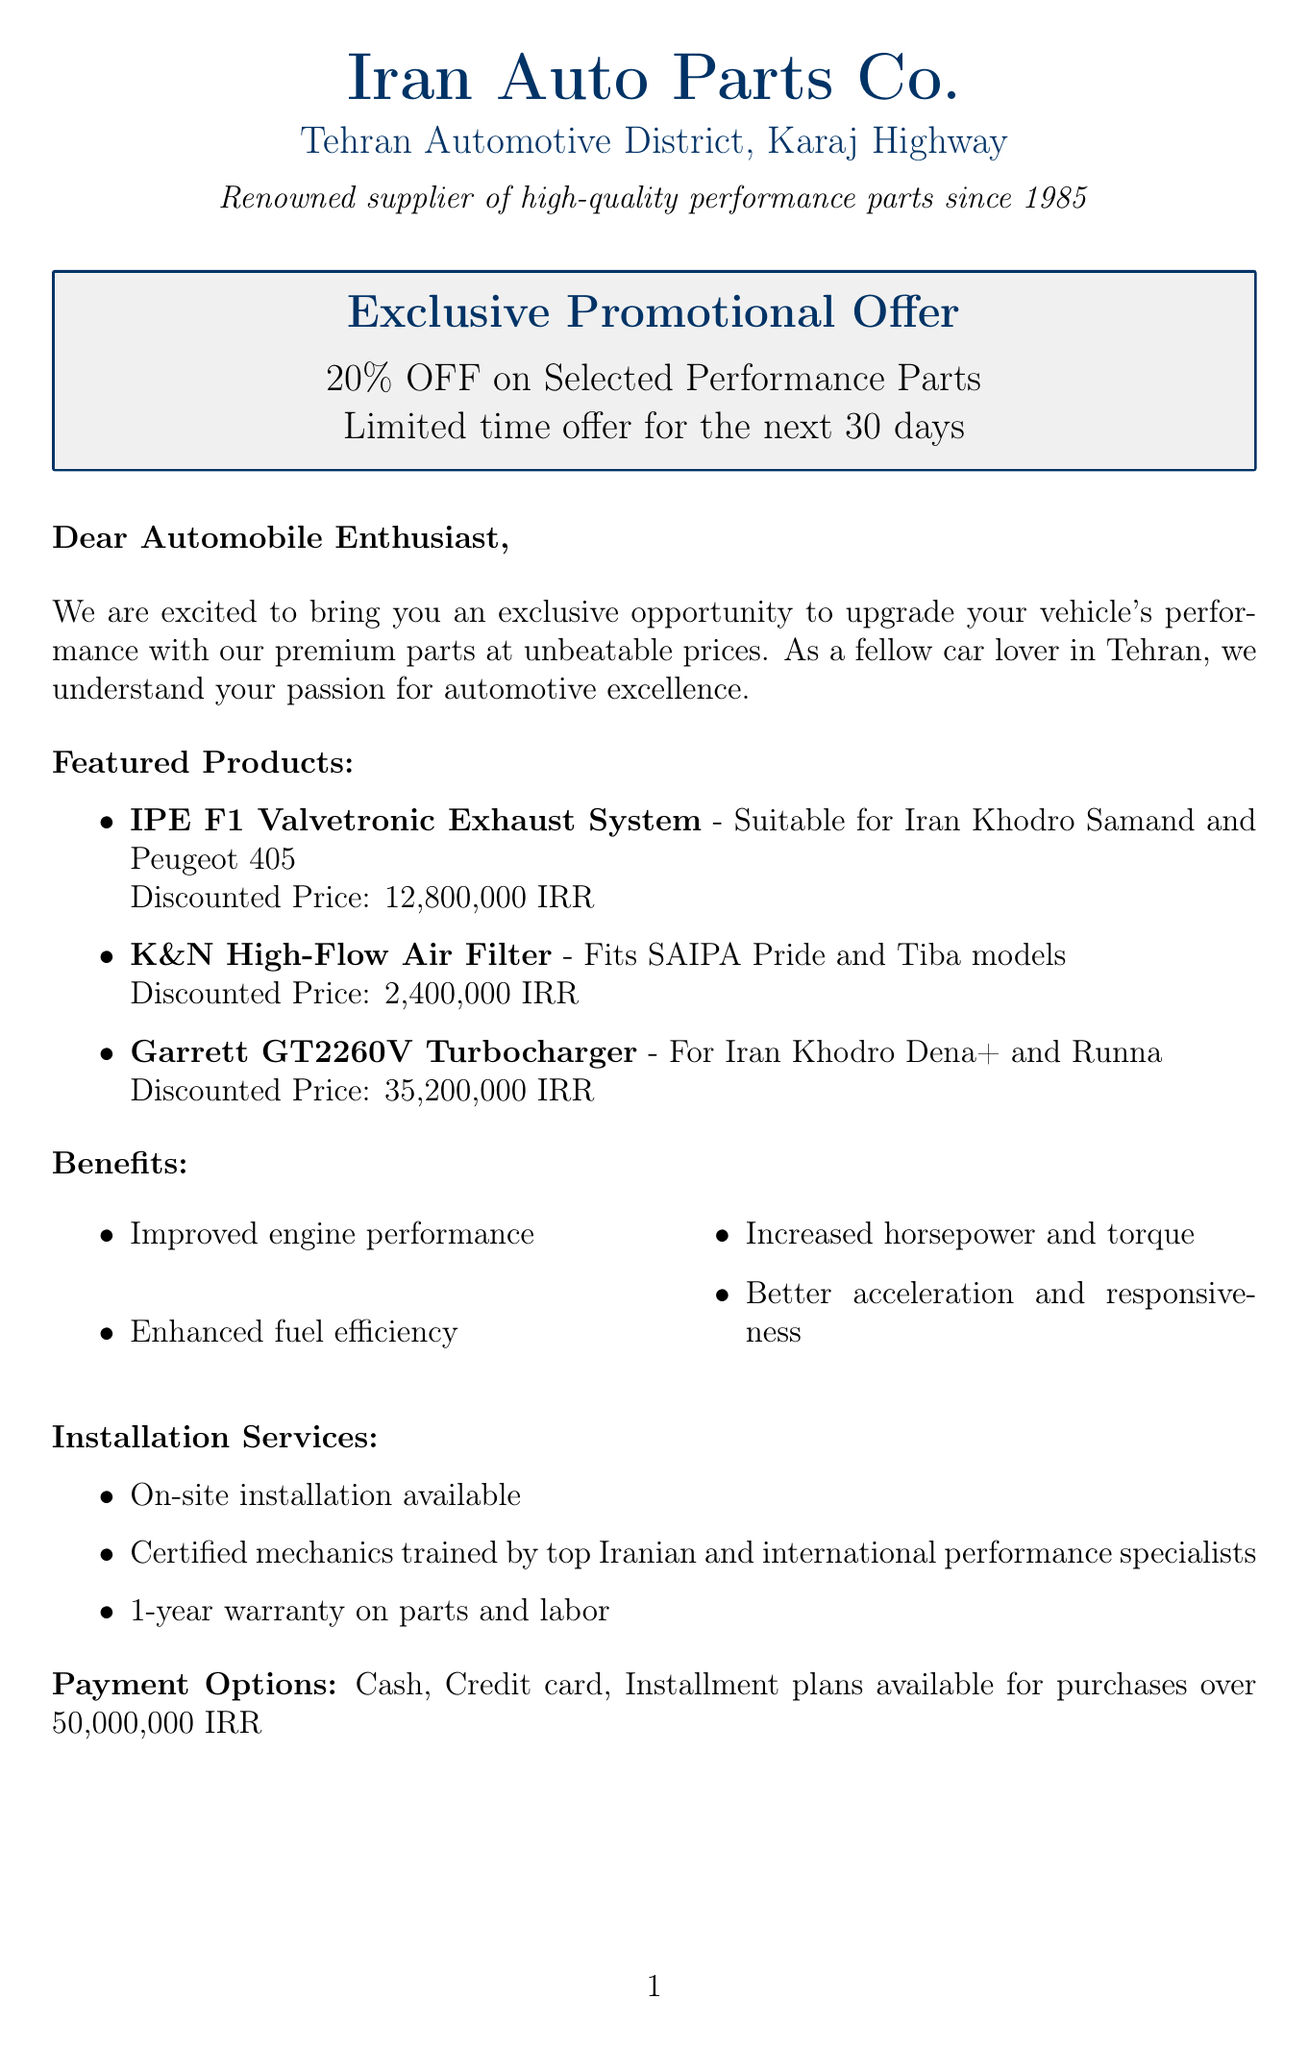What is the name of the supplier? The supplier's name is mentioned at the beginning of the document as "Iran Auto Parts Co."
Answer: Iran Auto Parts Co What is the duration of the promotional offer? The promotional offer duration is specified in the document as "Limited time offer for the next 30 days."
Answer: 30 days Which product is suitable for Iran Khodro Dena+? The document lists products and their compatibilities; the "Garrett GT2260V Turbocharger" is specifically mentioned for Iran Khodro Dena+.
Answer: Garrett GT2260V Turbocharger What is the discount percentage offered? The percentage of discount for the promotional offer is clearly stated as "20% OFF on Selected Performance Parts."
Answer: 20% What is included in the benefits section? The benefits section lists several advantages from the products; for instance, "Improved engine performance" is one of the benefits mentioned in the document.
Answer: Improved engine performance Who gave a testimonial? The document provides a testimonial from "Reza Ahmadi," highlighting their experience with the supplier's products.
Answer: Reza Ahmadi What types of payment are accepted? The document enumerates different methods of payment, mentioning "Cash" and "Credit card" specifically among other options.
Answer: Cash, Credit card When is the Tehran Drift Championship scheduled? The date for the Tehran Drift Championship is given in the document as taking place on "Next month, 15th-17th."
Answer: 15th-17th What kind of installation services are available? The document states that "On-site installation available," indicating that installation services can be provided at the customer's location.
Answer: On-site installation available 